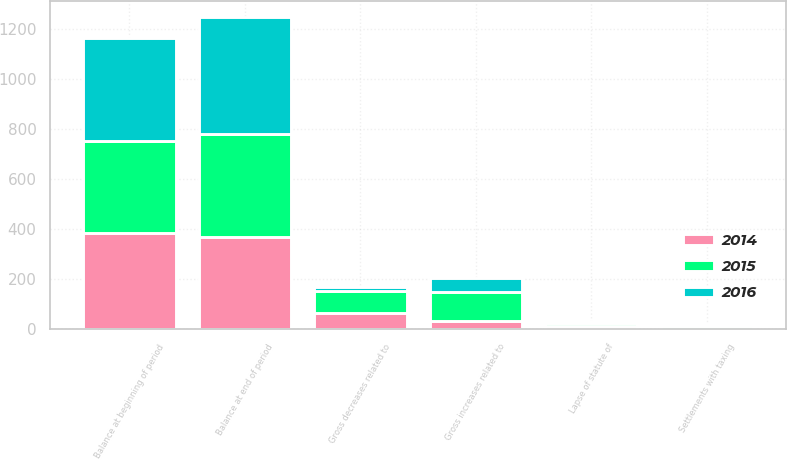<chart> <loc_0><loc_0><loc_500><loc_500><stacked_bar_chart><ecel><fcel>Balance at beginning of period<fcel>Gross increases related to<fcel>Gross decreases related to<fcel>Settlements with taxing<fcel>Lapse of statute of<fcel>Balance at end of period<nl><fcel>2016<fcel>410<fcel>59<fcel>13<fcel>9<fcel>8<fcel>469<nl><fcel>2015<fcel>370<fcel>114<fcel>88<fcel>9<fcel>10<fcel>410<nl><fcel>2014<fcel>383<fcel>34<fcel>67<fcel>3<fcel>15<fcel>370<nl></chart> 